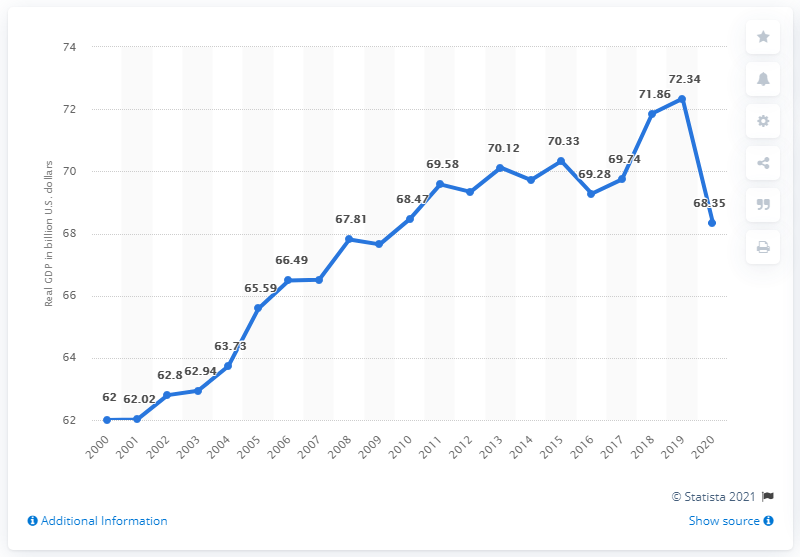Point out several critical features in this image. In 2020, the Gross Domestic Product (GDP) of West Virginia was 68.35. West Virginia's GDP in the previous year was $72.34 billion. 